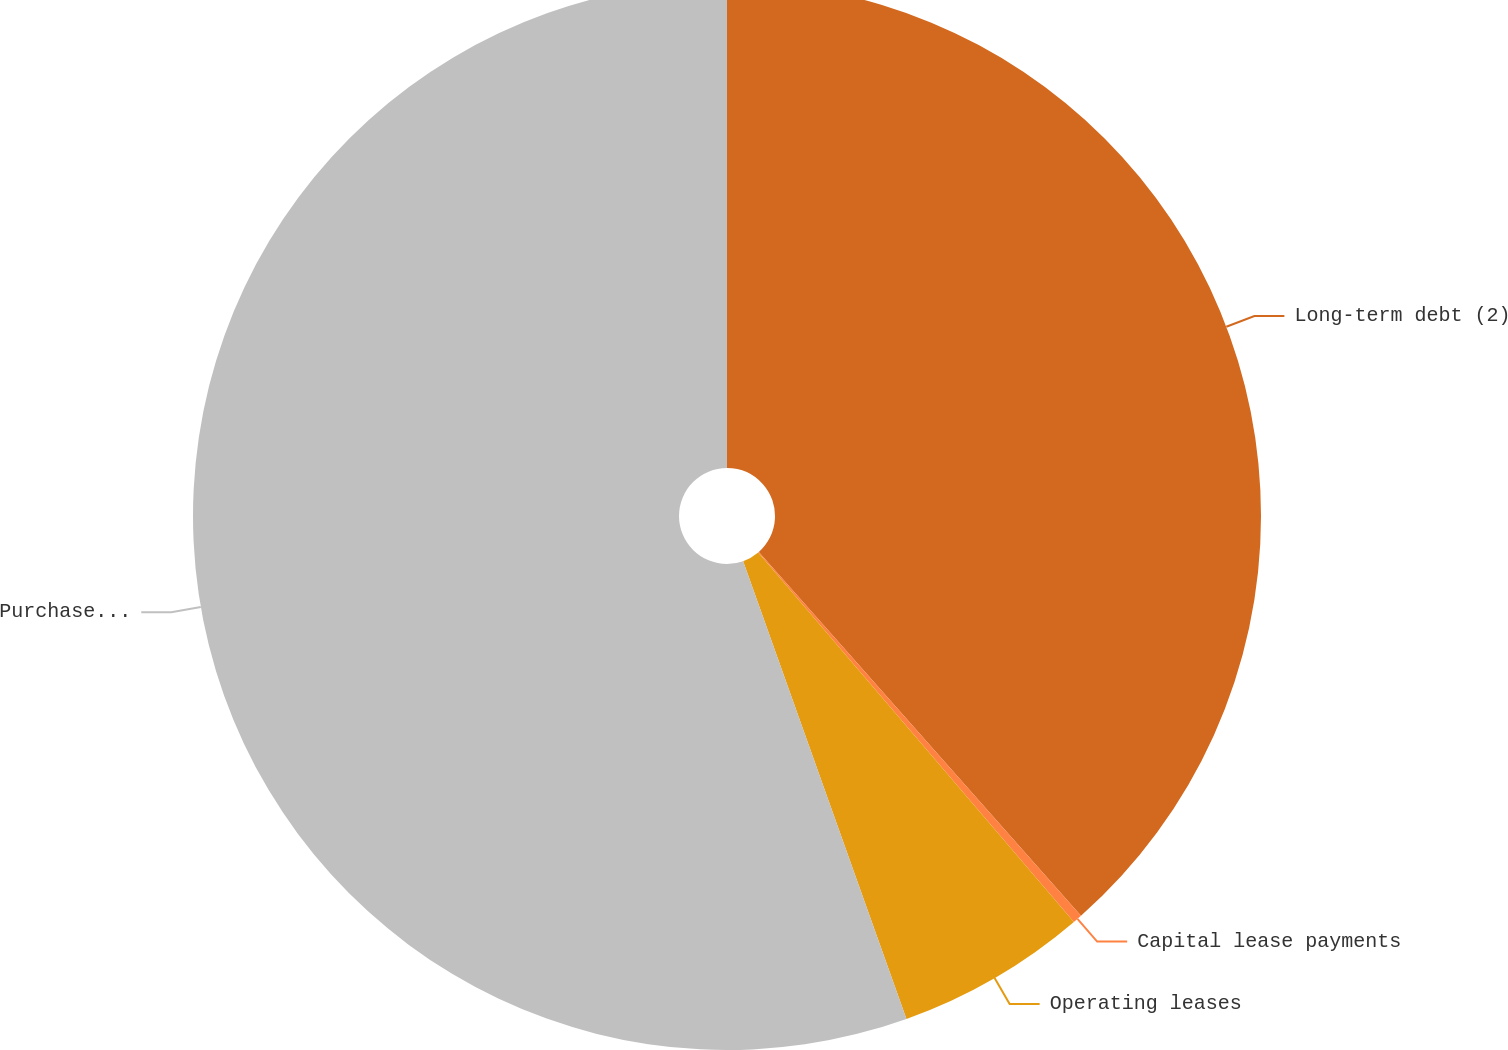Convert chart to OTSL. <chart><loc_0><loc_0><loc_500><loc_500><pie_chart><fcel>Long-term debt (2)<fcel>Capital lease payments<fcel>Operating leases<fcel>Purchase obligations (3)<nl><fcel>38.47%<fcel>0.28%<fcel>5.8%<fcel>55.46%<nl></chart> 